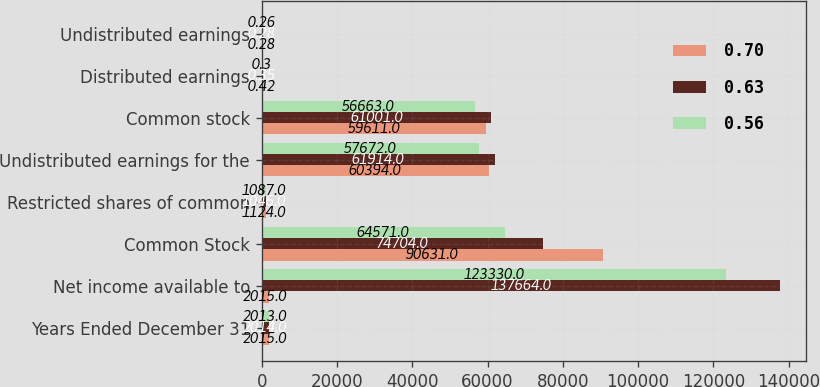Convert chart to OTSL. <chart><loc_0><loc_0><loc_500><loc_500><stacked_bar_chart><ecel><fcel>Years Ended December 31<fcel>Net income available to<fcel>Common Stock<fcel>Restricted shares of common<fcel>Undistributed earnings for the<fcel>Common stock<fcel>Distributed earnings<fcel>Undistributed earnings<nl><fcel>0.7<fcel>2015<fcel>2015<fcel>90631<fcel>1124<fcel>60394<fcel>59611<fcel>0.42<fcel>0.28<nl><fcel>0.63<fcel>2014<fcel>137664<fcel>74704<fcel>1046<fcel>61914<fcel>61001<fcel>0.35<fcel>0.28<nl><fcel>0.56<fcel>2013<fcel>123330<fcel>64571<fcel>1087<fcel>57672<fcel>56663<fcel>0.3<fcel>0.26<nl></chart> 